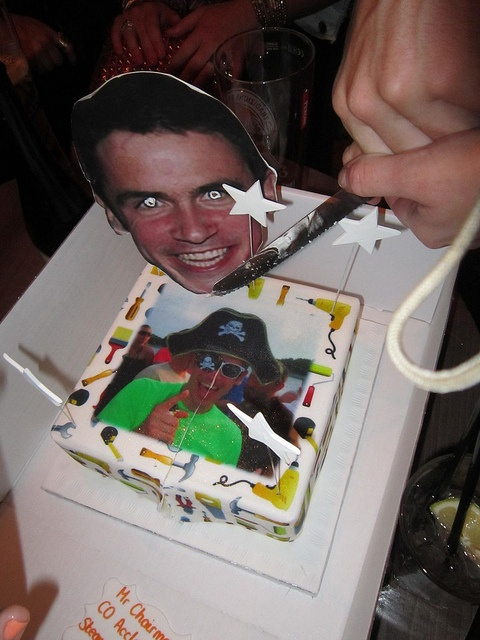Describe the objects in this image and their specific colors. I can see cake in black, darkgray, and lightgray tones, people in black, brown, and maroon tones, people in black, brown, and maroon tones, people in black, maroon, and green tones, and cup in black, gray, and darkgray tones in this image. 